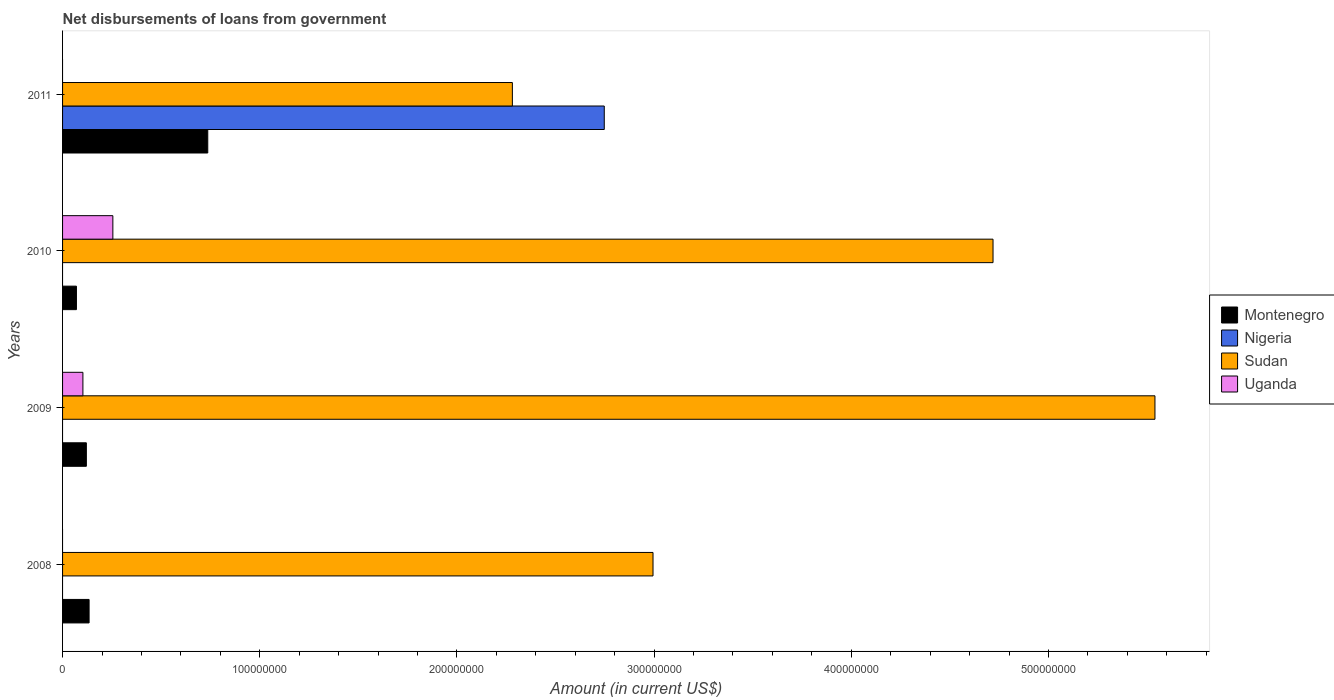How many different coloured bars are there?
Provide a short and direct response. 4. Are the number of bars per tick equal to the number of legend labels?
Your answer should be compact. No. How many bars are there on the 4th tick from the top?
Your answer should be very brief. 2. How many bars are there on the 1st tick from the bottom?
Offer a terse response. 2. In how many cases, is the number of bars for a given year not equal to the number of legend labels?
Your answer should be very brief. 4. What is the amount of loan disbursed from government in Nigeria in 2009?
Offer a terse response. 0. Across all years, what is the maximum amount of loan disbursed from government in Uganda?
Your response must be concise. 2.55e+07. What is the total amount of loan disbursed from government in Uganda in the graph?
Give a very brief answer. 3.58e+07. What is the difference between the amount of loan disbursed from government in Montenegro in 2008 and that in 2009?
Provide a short and direct response. 1.39e+06. What is the difference between the amount of loan disbursed from government in Nigeria in 2010 and the amount of loan disbursed from government in Sudan in 2011?
Your answer should be compact. -2.28e+08. What is the average amount of loan disbursed from government in Sudan per year?
Your answer should be compact. 3.88e+08. In the year 2009, what is the difference between the amount of loan disbursed from government in Uganda and amount of loan disbursed from government in Montenegro?
Give a very brief answer. -1.76e+06. In how many years, is the amount of loan disbursed from government in Montenegro greater than 140000000 US$?
Your response must be concise. 0. What is the ratio of the amount of loan disbursed from government in Montenegro in 2008 to that in 2009?
Your answer should be compact. 1.11. Is the amount of loan disbursed from government in Montenegro in 2010 less than that in 2011?
Give a very brief answer. Yes. What is the difference between the highest and the second highest amount of loan disbursed from government in Montenegro?
Ensure brevity in your answer.  6.02e+07. What is the difference between the highest and the lowest amount of loan disbursed from government in Montenegro?
Your answer should be compact. 6.66e+07. Is the sum of the amount of loan disbursed from government in Uganda in 2009 and 2010 greater than the maximum amount of loan disbursed from government in Montenegro across all years?
Provide a short and direct response. No. How many bars are there?
Your answer should be very brief. 11. Are all the bars in the graph horizontal?
Provide a succinct answer. Yes. How many years are there in the graph?
Offer a very short reply. 4. Does the graph contain any zero values?
Your answer should be very brief. Yes. Does the graph contain grids?
Offer a terse response. No. Where does the legend appear in the graph?
Your answer should be compact. Center right. How many legend labels are there?
Offer a very short reply. 4. What is the title of the graph?
Provide a succinct answer. Net disbursements of loans from government. Does "High income: nonOECD" appear as one of the legend labels in the graph?
Offer a terse response. No. What is the label or title of the Y-axis?
Keep it short and to the point. Years. What is the Amount (in current US$) of Montenegro in 2008?
Make the answer very short. 1.35e+07. What is the Amount (in current US$) of Sudan in 2008?
Keep it short and to the point. 2.99e+08. What is the Amount (in current US$) of Montenegro in 2009?
Ensure brevity in your answer.  1.21e+07. What is the Amount (in current US$) of Nigeria in 2009?
Ensure brevity in your answer.  0. What is the Amount (in current US$) in Sudan in 2009?
Your response must be concise. 5.54e+08. What is the Amount (in current US$) in Uganda in 2009?
Offer a terse response. 1.03e+07. What is the Amount (in current US$) of Montenegro in 2010?
Offer a very short reply. 7.04e+06. What is the Amount (in current US$) of Nigeria in 2010?
Make the answer very short. 0. What is the Amount (in current US$) in Sudan in 2010?
Give a very brief answer. 4.72e+08. What is the Amount (in current US$) in Uganda in 2010?
Offer a very short reply. 2.55e+07. What is the Amount (in current US$) of Montenegro in 2011?
Keep it short and to the point. 7.36e+07. What is the Amount (in current US$) of Nigeria in 2011?
Your answer should be very brief. 2.75e+08. What is the Amount (in current US$) of Sudan in 2011?
Your answer should be compact. 2.28e+08. What is the Amount (in current US$) of Uganda in 2011?
Your response must be concise. 0. Across all years, what is the maximum Amount (in current US$) of Montenegro?
Offer a very short reply. 7.36e+07. Across all years, what is the maximum Amount (in current US$) in Nigeria?
Give a very brief answer. 2.75e+08. Across all years, what is the maximum Amount (in current US$) of Sudan?
Your answer should be compact. 5.54e+08. Across all years, what is the maximum Amount (in current US$) of Uganda?
Your response must be concise. 2.55e+07. Across all years, what is the minimum Amount (in current US$) in Montenegro?
Ensure brevity in your answer.  7.04e+06. Across all years, what is the minimum Amount (in current US$) in Sudan?
Your answer should be very brief. 2.28e+08. Across all years, what is the minimum Amount (in current US$) of Uganda?
Offer a very short reply. 0. What is the total Amount (in current US$) of Montenegro in the graph?
Make the answer very short. 1.06e+08. What is the total Amount (in current US$) of Nigeria in the graph?
Give a very brief answer. 2.75e+08. What is the total Amount (in current US$) in Sudan in the graph?
Your answer should be very brief. 1.55e+09. What is the total Amount (in current US$) in Uganda in the graph?
Your answer should be compact. 3.58e+07. What is the difference between the Amount (in current US$) of Montenegro in 2008 and that in 2009?
Provide a succinct answer. 1.39e+06. What is the difference between the Amount (in current US$) of Sudan in 2008 and that in 2009?
Provide a short and direct response. -2.55e+08. What is the difference between the Amount (in current US$) of Montenegro in 2008 and that in 2010?
Offer a terse response. 6.42e+06. What is the difference between the Amount (in current US$) of Sudan in 2008 and that in 2010?
Keep it short and to the point. -1.72e+08. What is the difference between the Amount (in current US$) of Montenegro in 2008 and that in 2011?
Your answer should be very brief. -6.02e+07. What is the difference between the Amount (in current US$) in Sudan in 2008 and that in 2011?
Offer a terse response. 7.13e+07. What is the difference between the Amount (in current US$) in Montenegro in 2009 and that in 2010?
Keep it short and to the point. 5.03e+06. What is the difference between the Amount (in current US$) in Sudan in 2009 and that in 2010?
Ensure brevity in your answer.  8.21e+07. What is the difference between the Amount (in current US$) in Uganda in 2009 and that in 2010?
Provide a short and direct response. -1.52e+07. What is the difference between the Amount (in current US$) in Montenegro in 2009 and that in 2011?
Offer a terse response. -6.16e+07. What is the difference between the Amount (in current US$) in Sudan in 2009 and that in 2011?
Provide a succinct answer. 3.26e+08. What is the difference between the Amount (in current US$) of Montenegro in 2010 and that in 2011?
Ensure brevity in your answer.  -6.66e+07. What is the difference between the Amount (in current US$) of Sudan in 2010 and that in 2011?
Offer a terse response. 2.44e+08. What is the difference between the Amount (in current US$) in Montenegro in 2008 and the Amount (in current US$) in Sudan in 2009?
Your answer should be very brief. -5.41e+08. What is the difference between the Amount (in current US$) of Montenegro in 2008 and the Amount (in current US$) of Uganda in 2009?
Your response must be concise. 3.14e+06. What is the difference between the Amount (in current US$) in Sudan in 2008 and the Amount (in current US$) in Uganda in 2009?
Provide a short and direct response. 2.89e+08. What is the difference between the Amount (in current US$) of Montenegro in 2008 and the Amount (in current US$) of Sudan in 2010?
Offer a terse response. -4.58e+08. What is the difference between the Amount (in current US$) of Montenegro in 2008 and the Amount (in current US$) of Uganda in 2010?
Your answer should be very brief. -1.20e+07. What is the difference between the Amount (in current US$) in Sudan in 2008 and the Amount (in current US$) in Uganda in 2010?
Your response must be concise. 2.74e+08. What is the difference between the Amount (in current US$) in Montenegro in 2008 and the Amount (in current US$) in Nigeria in 2011?
Give a very brief answer. -2.61e+08. What is the difference between the Amount (in current US$) of Montenegro in 2008 and the Amount (in current US$) of Sudan in 2011?
Ensure brevity in your answer.  -2.15e+08. What is the difference between the Amount (in current US$) in Montenegro in 2009 and the Amount (in current US$) in Sudan in 2010?
Provide a succinct answer. -4.60e+08. What is the difference between the Amount (in current US$) of Montenegro in 2009 and the Amount (in current US$) of Uganda in 2010?
Your answer should be very brief. -1.34e+07. What is the difference between the Amount (in current US$) in Sudan in 2009 and the Amount (in current US$) in Uganda in 2010?
Ensure brevity in your answer.  5.29e+08. What is the difference between the Amount (in current US$) in Montenegro in 2009 and the Amount (in current US$) in Nigeria in 2011?
Ensure brevity in your answer.  -2.63e+08. What is the difference between the Amount (in current US$) in Montenegro in 2009 and the Amount (in current US$) in Sudan in 2011?
Offer a very short reply. -2.16e+08. What is the difference between the Amount (in current US$) in Montenegro in 2010 and the Amount (in current US$) in Nigeria in 2011?
Provide a succinct answer. -2.68e+08. What is the difference between the Amount (in current US$) of Montenegro in 2010 and the Amount (in current US$) of Sudan in 2011?
Your response must be concise. -2.21e+08. What is the average Amount (in current US$) in Montenegro per year?
Offer a terse response. 2.66e+07. What is the average Amount (in current US$) in Nigeria per year?
Keep it short and to the point. 6.87e+07. What is the average Amount (in current US$) in Sudan per year?
Make the answer very short. 3.88e+08. What is the average Amount (in current US$) in Uganda per year?
Your response must be concise. 8.95e+06. In the year 2008, what is the difference between the Amount (in current US$) in Montenegro and Amount (in current US$) in Sudan?
Your response must be concise. -2.86e+08. In the year 2009, what is the difference between the Amount (in current US$) of Montenegro and Amount (in current US$) of Sudan?
Give a very brief answer. -5.42e+08. In the year 2009, what is the difference between the Amount (in current US$) in Montenegro and Amount (in current US$) in Uganda?
Your answer should be very brief. 1.76e+06. In the year 2009, what is the difference between the Amount (in current US$) of Sudan and Amount (in current US$) of Uganda?
Give a very brief answer. 5.44e+08. In the year 2010, what is the difference between the Amount (in current US$) of Montenegro and Amount (in current US$) of Sudan?
Ensure brevity in your answer.  -4.65e+08. In the year 2010, what is the difference between the Amount (in current US$) in Montenegro and Amount (in current US$) in Uganda?
Ensure brevity in your answer.  -1.85e+07. In the year 2010, what is the difference between the Amount (in current US$) of Sudan and Amount (in current US$) of Uganda?
Provide a short and direct response. 4.46e+08. In the year 2011, what is the difference between the Amount (in current US$) of Montenegro and Amount (in current US$) of Nigeria?
Provide a succinct answer. -2.01e+08. In the year 2011, what is the difference between the Amount (in current US$) in Montenegro and Amount (in current US$) in Sudan?
Your answer should be very brief. -1.54e+08. In the year 2011, what is the difference between the Amount (in current US$) in Nigeria and Amount (in current US$) in Sudan?
Offer a very short reply. 4.66e+07. What is the ratio of the Amount (in current US$) of Montenegro in 2008 to that in 2009?
Offer a very short reply. 1.11. What is the ratio of the Amount (in current US$) of Sudan in 2008 to that in 2009?
Provide a short and direct response. 0.54. What is the ratio of the Amount (in current US$) in Montenegro in 2008 to that in 2010?
Provide a short and direct response. 1.91. What is the ratio of the Amount (in current US$) in Sudan in 2008 to that in 2010?
Offer a very short reply. 0.63. What is the ratio of the Amount (in current US$) of Montenegro in 2008 to that in 2011?
Ensure brevity in your answer.  0.18. What is the ratio of the Amount (in current US$) in Sudan in 2008 to that in 2011?
Offer a very short reply. 1.31. What is the ratio of the Amount (in current US$) in Montenegro in 2009 to that in 2010?
Provide a short and direct response. 1.72. What is the ratio of the Amount (in current US$) in Sudan in 2009 to that in 2010?
Your answer should be very brief. 1.17. What is the ratio of the Amount (in current US$) of Uganda in 2009 to that in 2010?
Your response must be concise. 0.4. What is the ratio of the Amount (in current US$) in Montenegro in 2009 to that in 2011?
Provide a succinct answer. 0.16. What is the ratio of the Amount (in current US$) of Sudan in 2009 to that in 2011?
Your answer should be very brief. 2.43. What is the ratio of the Amount (in current US$) in Montenegro in 2010 to that in 2011?
Provide a succinct answer. 0.1. What is the ratio of the Amount (in current US$) in Sudan in 2010 to that in 2011?
Keep it short and to the point. 2.07. What is the difference between the highest and the second highest Amount (in current US$) in Montenegro?
Provide a short and direct response. 6.02e+07. What is the difference between the highest and the second highest Amount (in current US$) in Sudan?
Give a very brief answer. 8.21e+07. What is the difference between the highest and the lowest Amount (in current US$) of Montenegro?
Offer a terse response. 6.66e+07. What is the difference between the highest and the lowest Amount (in current US$) of Nigeria?
Your answer should be compact. 2.75e+08. What is the difference between the highest and the lowest Amount (in current US$) in Sudan?
Offer a very short reply. 3.26e+08. What is the difference between the highest and the lowest Amount (in current US$) in Uganda?
Your answer should be very brief. 2.55e+07. 